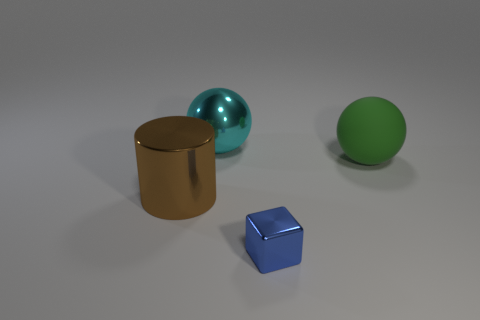Add 4 large red blocks. How many objects exist? 8 Subtract all cylinders. How many objects are left? 3 Subtract all spheres. Subtract all cyan balls. How many objects are left? 1 Add 4 tiny blue objects. How many tiny blue objects are left? 5 Add 2 big green cylinders. How many big green cylinders exist? 2 Subtract 0 gray cylinders. How many objects are left? 4 